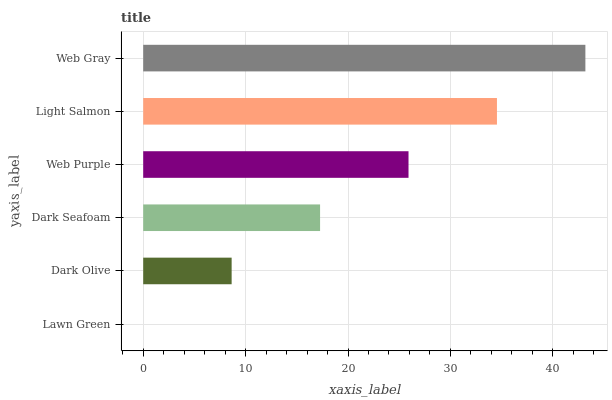Is Lawn Green the minimum?
Answer yes or no. Yes. Is Web Gray the maximum?
Answer yes or no. Yes. Is Dark Olive the minimum?
Answer yes or no. No. Is Dark Olive the maximum?
Answer yes or no. No. Is Dark Olive greater than Lawn Green?
Answer yes or no. Yes. Is Lawn Green less than Dark Olive?
Answer yes or no. Yes. Is Lawn Green greater than Dark Olive?
Answer yes or no. No. Is Dark Olive less than Lawn Green?
Answer yes or no. No. Is Web Purple the high median?
Answer yes or no. Yes. Is Dark Seafoam the low median?
Answer yes or no. Yes. Is Lawn Green the high median?
Answer yes or no. No. Is Web Purple the low median?
Answer yes or no. No. 